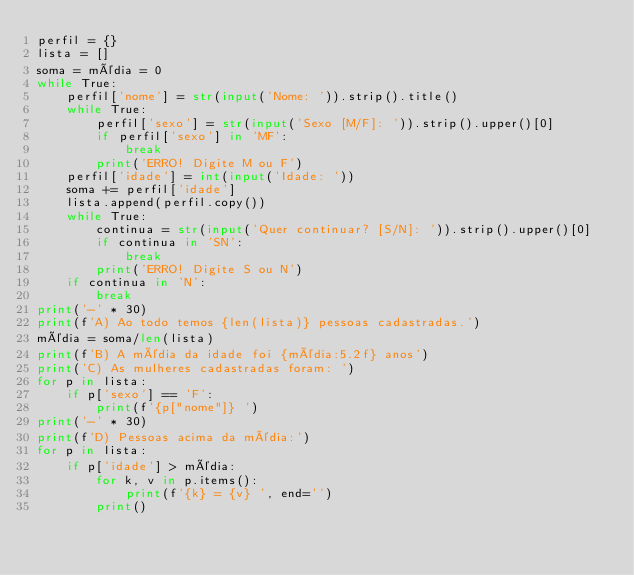Convert code to text. <code><loc_0><loc_0><loc_500><loc_500><_Python_>perfil = {}
lista = []
soma = média = 0
while True:
    perfil['nome'] = str(input('Nome: ')).strip().title()
    while True:
        perfil['sexo'] = str(input('Sexo [M/F]: ')).strip().upper()[0]
        if perfil['sexo'] in 'MF':
            break
        print('ERRO! Digite M ou F')
    perfil['idade'] = int(input('Idade: '))
    soma += perfil['idade']
    lista.append(perfil.copy())
    while True:
        continua = str(input('Quer continuar? [S/N]: ')).strip().upper()[0]
        if continua in 'SN':
            break
        print('ERRO! Digite S ou N')
    if continua in 'N':
        break
print('-' * 30)
print(f'A) Ao todo temos {len(lista)} pessoas cadastradas.')
média = soma/len(lista)
print(f'B) A média da idade foi {média:5.2f} anos')
print('C) As mulheres cadastradas foram: ')
for p in lista:
    if p['sexo'] == 'F':
        print(f'{p["nome"]} ')
print('-' * 30)
print(f'D) Pessoas acima da média:')
for p in lista:
    if p['idade'] > média:
        for k, v in p.items():
            print(f'{k} = {v} ', end='')
        print()
</code> 